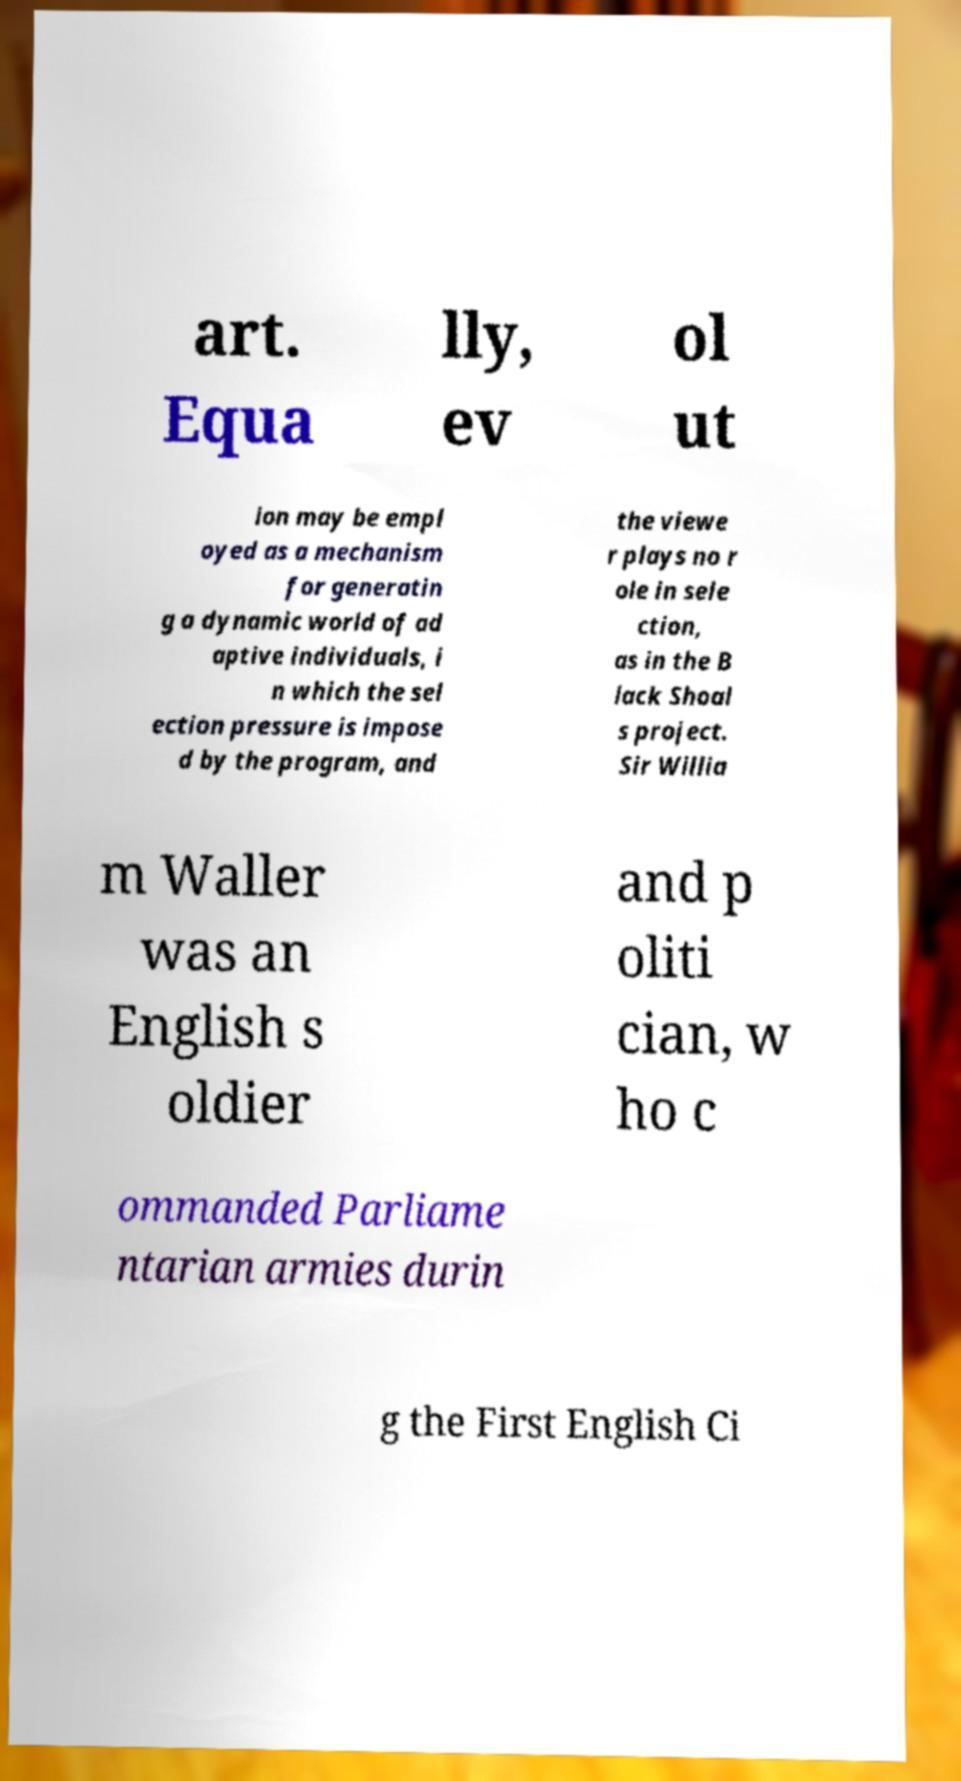Please identify and transcribe the text found in this image. art. Equa lly, ev ol ut ion may be empl oyed as a mechanism for generatin g a dynamic world of ad aptive individuals, i n which the sel ection pressure is impose d by the program, and the viewe r plays no r ole in sele ction, as in the B lack Shoal s project. Sir Willia m Waller was an English s oldier and p oliti cian, w ho c ommanded Parliame ntarian armies durin g the First English Ci 